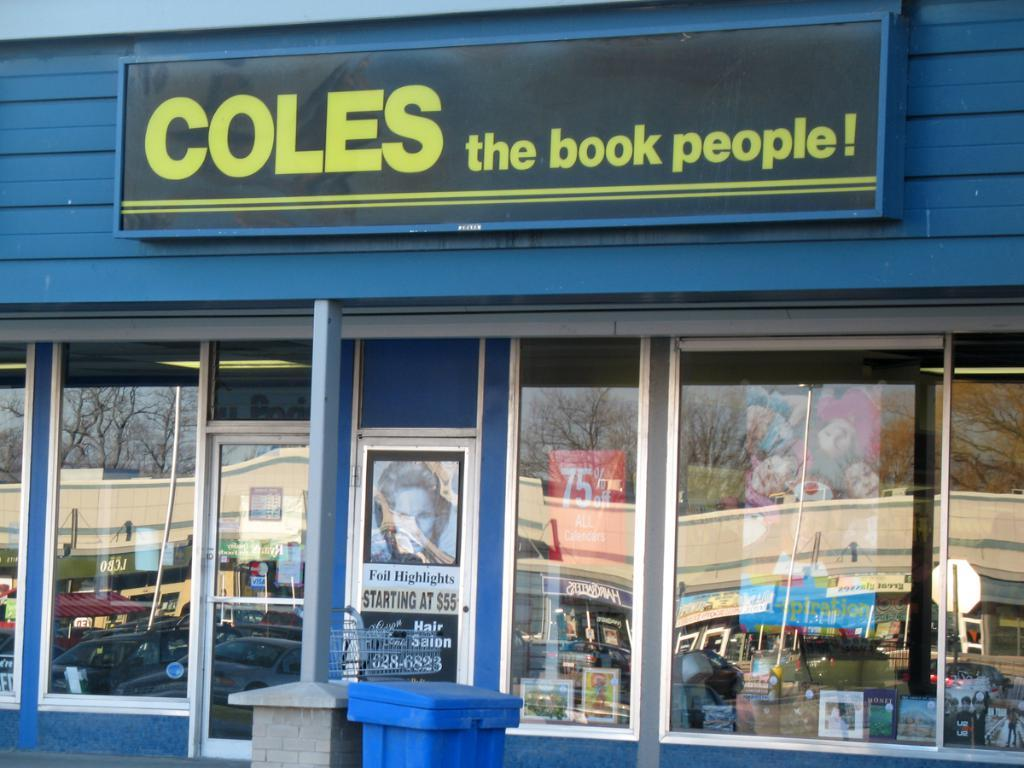What type of establishment is depicted in the image? There is a store front in the image. What feature is present on the store front? The store front has a glass window. What can be seen on the glass window? There are reflections of buildings on the glass window. What object is located in front of the store? There is a dustbin in front of the store. What type of vase is displayed on the store's shelves in the image? There is no vase visible in the image; the focus is on the store front, glass window, and reflections. What invention is being advertised on the store's sign in the image? There is no specific invention mentioned or advertised on the store's sign in the image. 